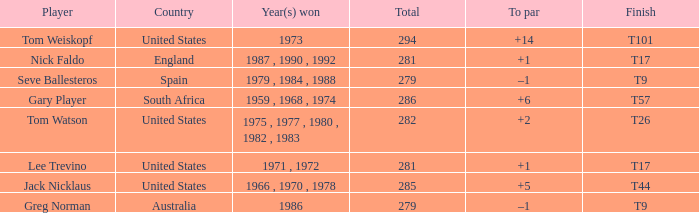What country is Greg Norman from? Australia. Parse the table in full. {'header': ['Player', 'Country', 'Year(s) won', 'Total', 'To par', 'Finish'], 'rows': [['Tom Weiskopf', 'United States', '1973', '294', '+14', 'T101'], ['Nick Faldo', 'England', '1987 , 1990 , 1992', '281', '+1', 'T17'], ['Seve Ballesteros', 'Spain', '1979 , 1984 , 1988', '279', '–1', 'T9'], ['Gary Player', 'South Africa', '1959 , 1968 , 1974', '286', '+6', 'T57'], ['Tom Watson', 'United States', '1975 , 1977 , 1980 , 1982 , 1983', '282', '+2', 'T26'], ['Lee Trevino', 'United States', '1971 , 1972', '281', '+1', 'T17'], ['Jack Nicklaus', 'United States', '1966 , 1970 , 1978', '285', '+5', 'T44'], ['Greg Norman', 'Australia', '1986', '279', '–1', 'T9']]} 